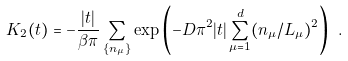<formula> <loc_0><loc_0><loc_500><loc_500>K _ { 2 } ( t ) = - \frac { | t | } { \beta \pi } \sum _ { \{ n _ { \mu } \} } \exp { \left ( - D \pi ^ { 2 } | t | \sum _ { \mu = 1 } ^ { d } ( n _ { \mu } / L _ { \mu } ) ^ { 2 } \right ) } \ .</formula> 